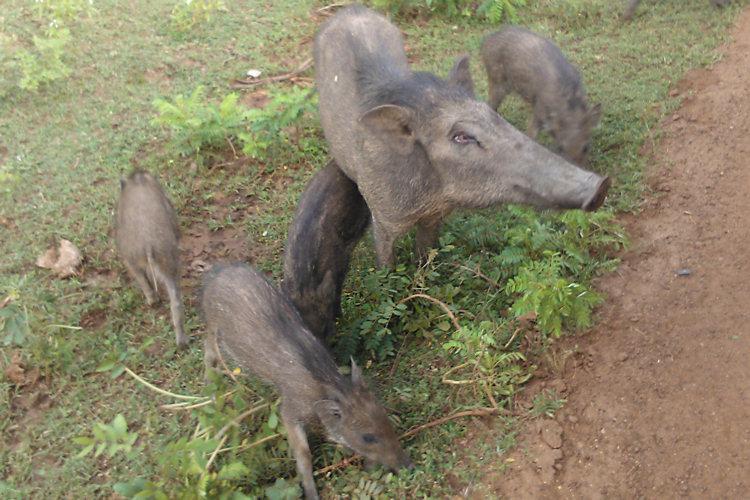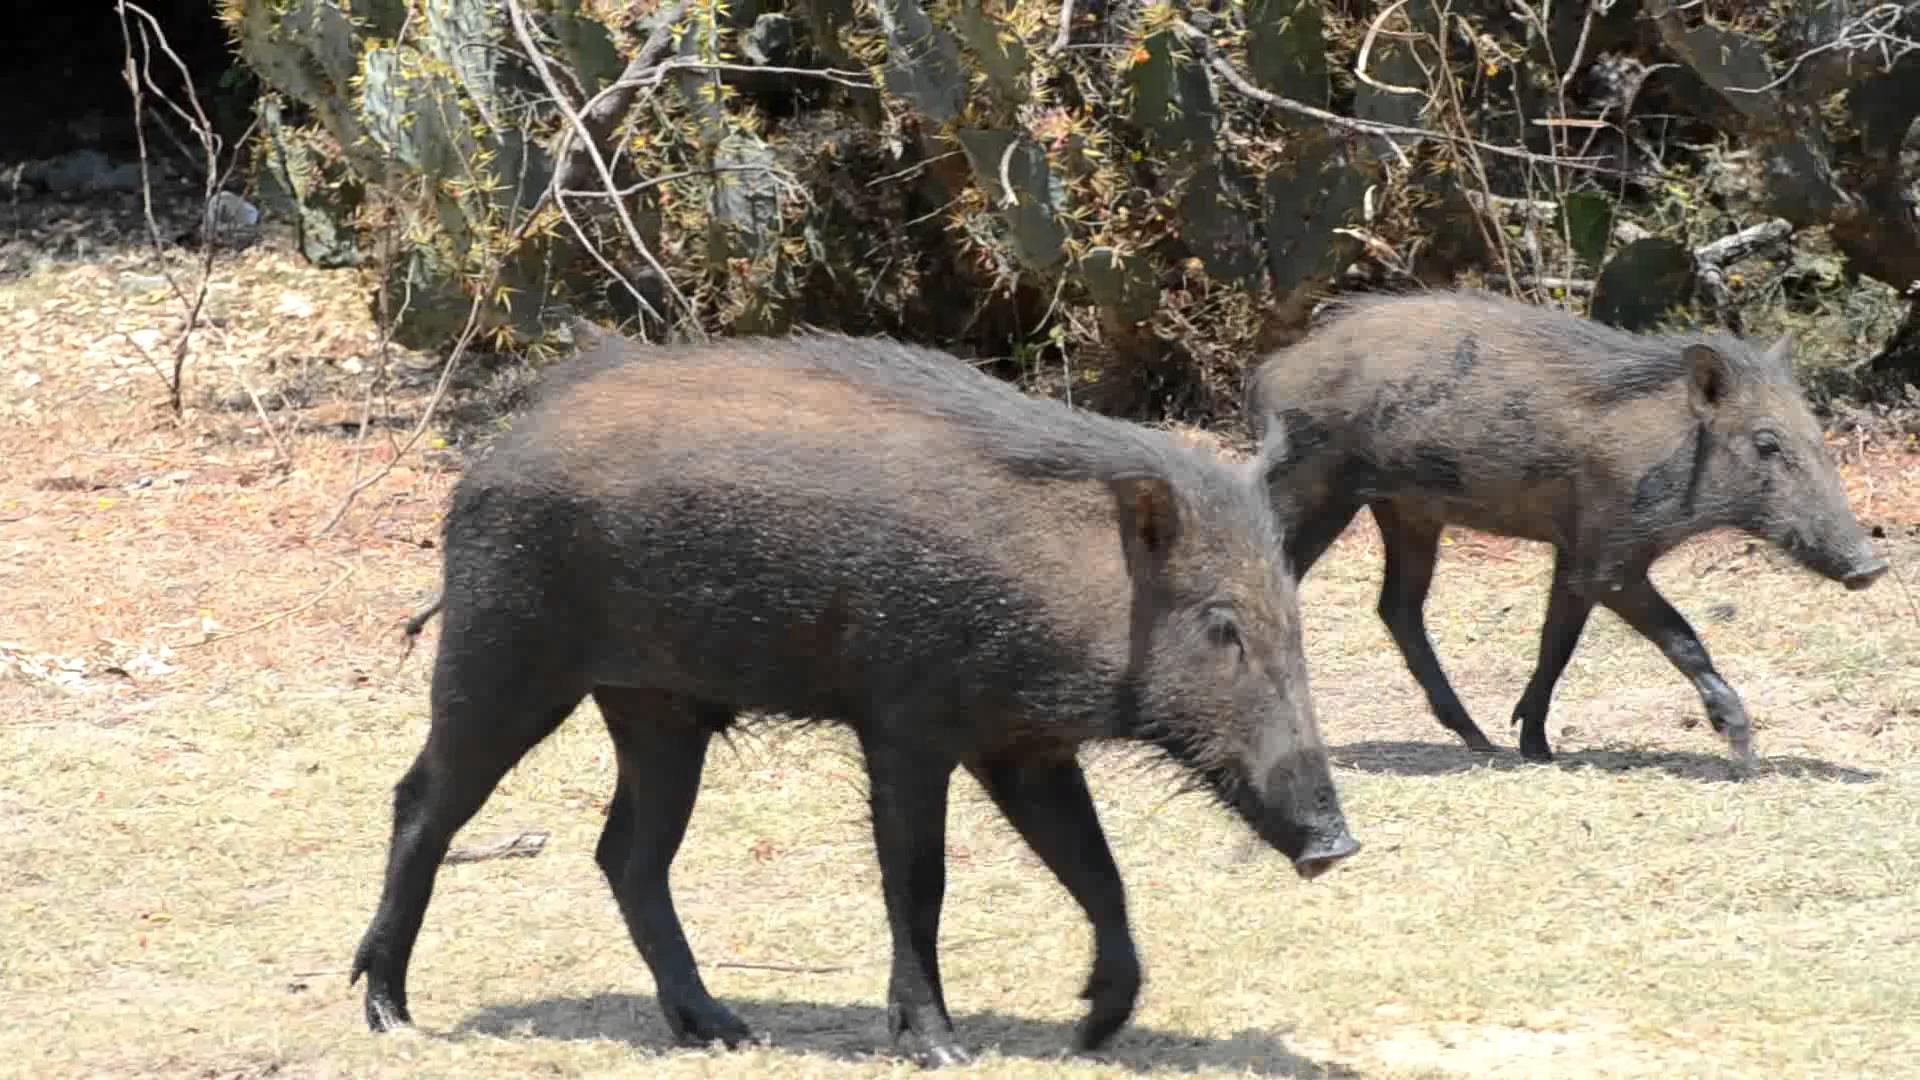The first image is the image on the left, the second image is the image on the right. For the images displayed, is the sentence "An image shows a boar with its spotted deer-like prey animal." factually correct? Answer yes or no. No. The first image is the image on the left, the second image is the image on the right. Analyze the images presented: Is the assertion "a hog is standing in water." valid? Answer yes or no. No. 